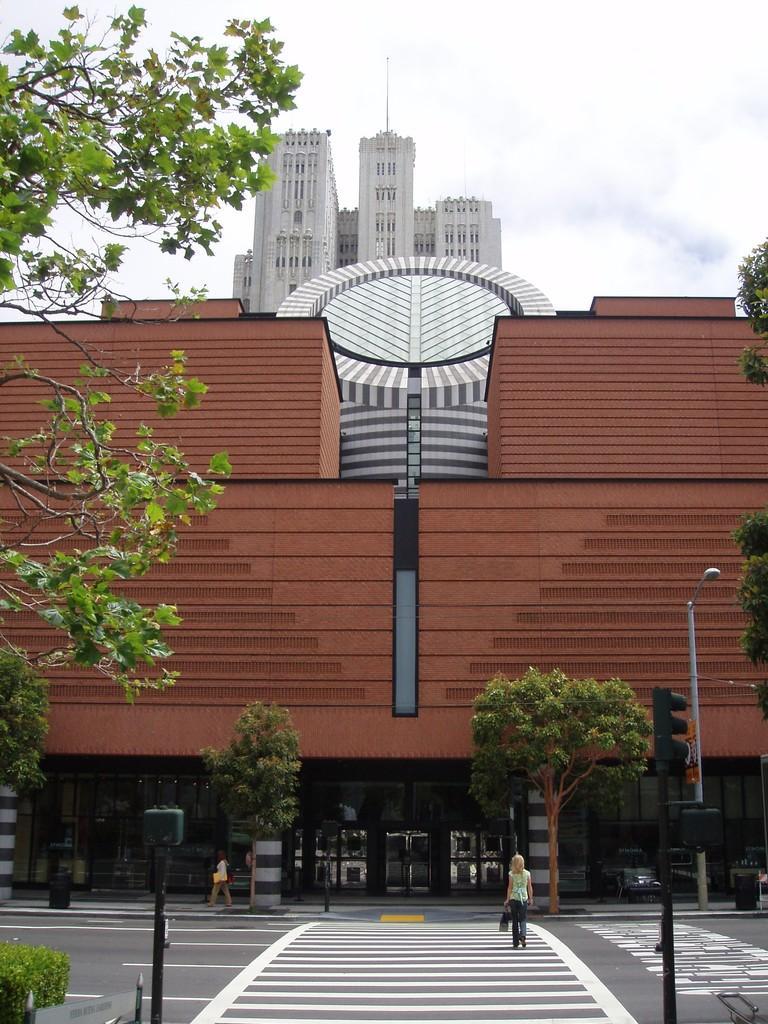Can you describe this image briefly? This picture is clicked outside. In the center we can see a person walking on the zebra crossing and we can see the traffic light, lamp post and a person walking on the ground, we can see the plants, trees and some other objects and we can see the buildings. In the background we can see the sky and some other objects. 